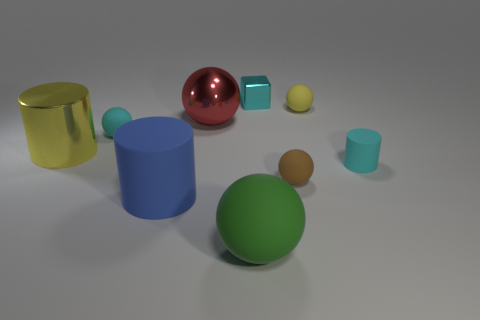Which objects appear to have smooth surfaces? The red metal sphere, the green spherical object, and the blue cylinder exhibit smooth surfaces with no visible texture, indicative of a sleek finish. The reflective quality of the red sphere particularly emphasizes its smoothness. 